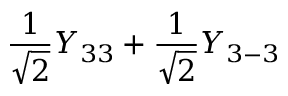Convert formula to latex. <formula><loc_0><loc_0><loc_500><loc_500>\frac { 1 } { \sqrt { 2 } } Y _ { 3 3 } + \frac { 1 } { \sqrt { 2 } } Y _ { 3 - 3 }</formula> 